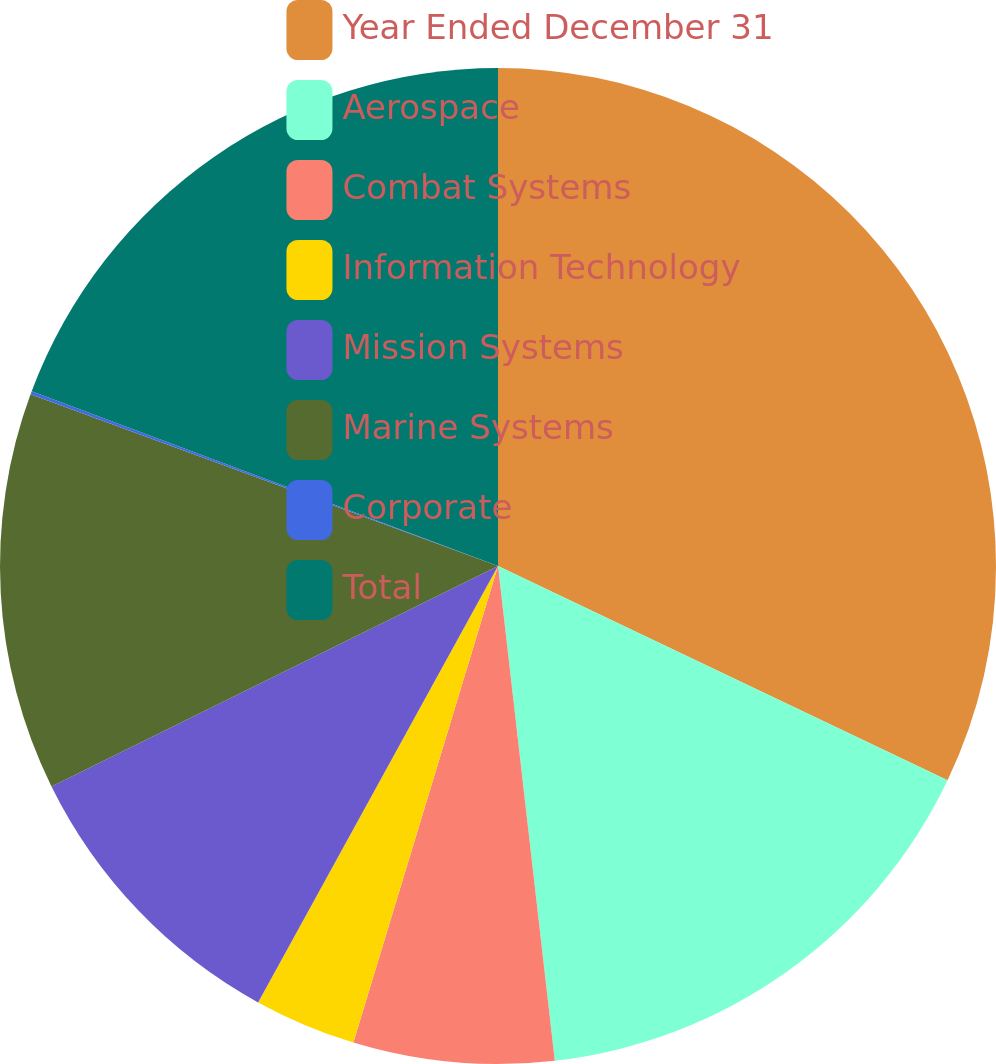Convert chart. <chart><loc_0><loc_0><loc_500><loc_500><pie_chart><fcel>Year Ended December 31<fcel>Aerospace<fcel>Combat Systems<fcel>Information Technology<fcel>Mission Systems<fcel>Marine Systems<fcel>Corporate<fcel>Total<nl><fcel>32.08%<fcel>16.1%<fcel>6.51%<fcel>3.31%<fcel>9.7%<fcel>12.9%<fcel>0.11%<fcel>19.29%<nl></chart> 